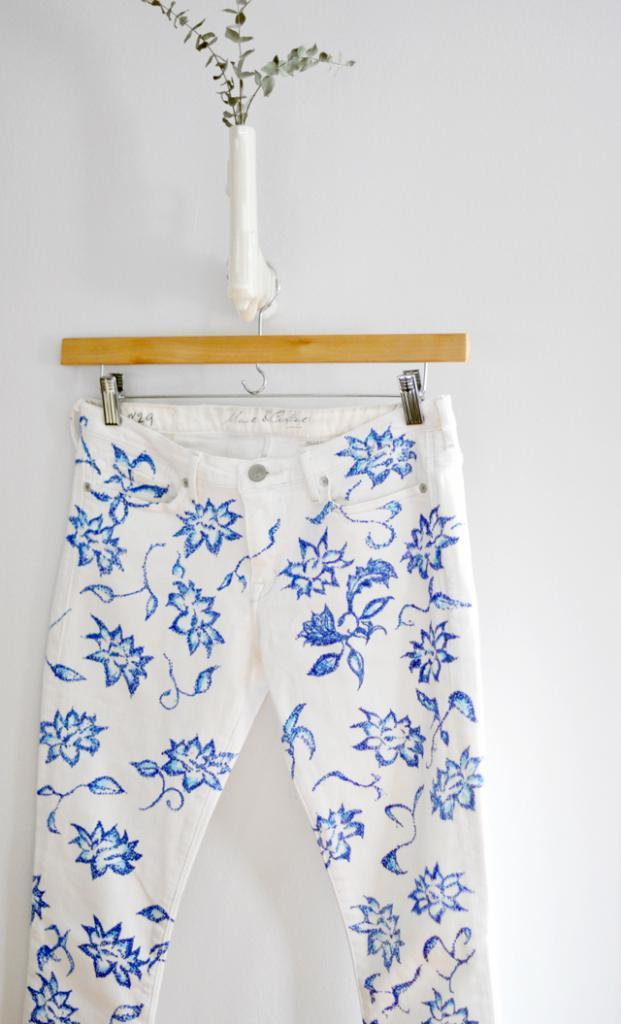What is hanging in the center of the image? There is a pant hanging on a hanger in the center of the image. What else can be seen in the image besides the hanging pant? There is a plant in the image. What is visible in the background of the image? There is a wall in the background of the image. Where is the basket located in the image? There is no basket present in the image. Can you describe the self-awareness of the plant in the image? The plant in the image does not exhibit self-awareness, as it is an inanimate object. 